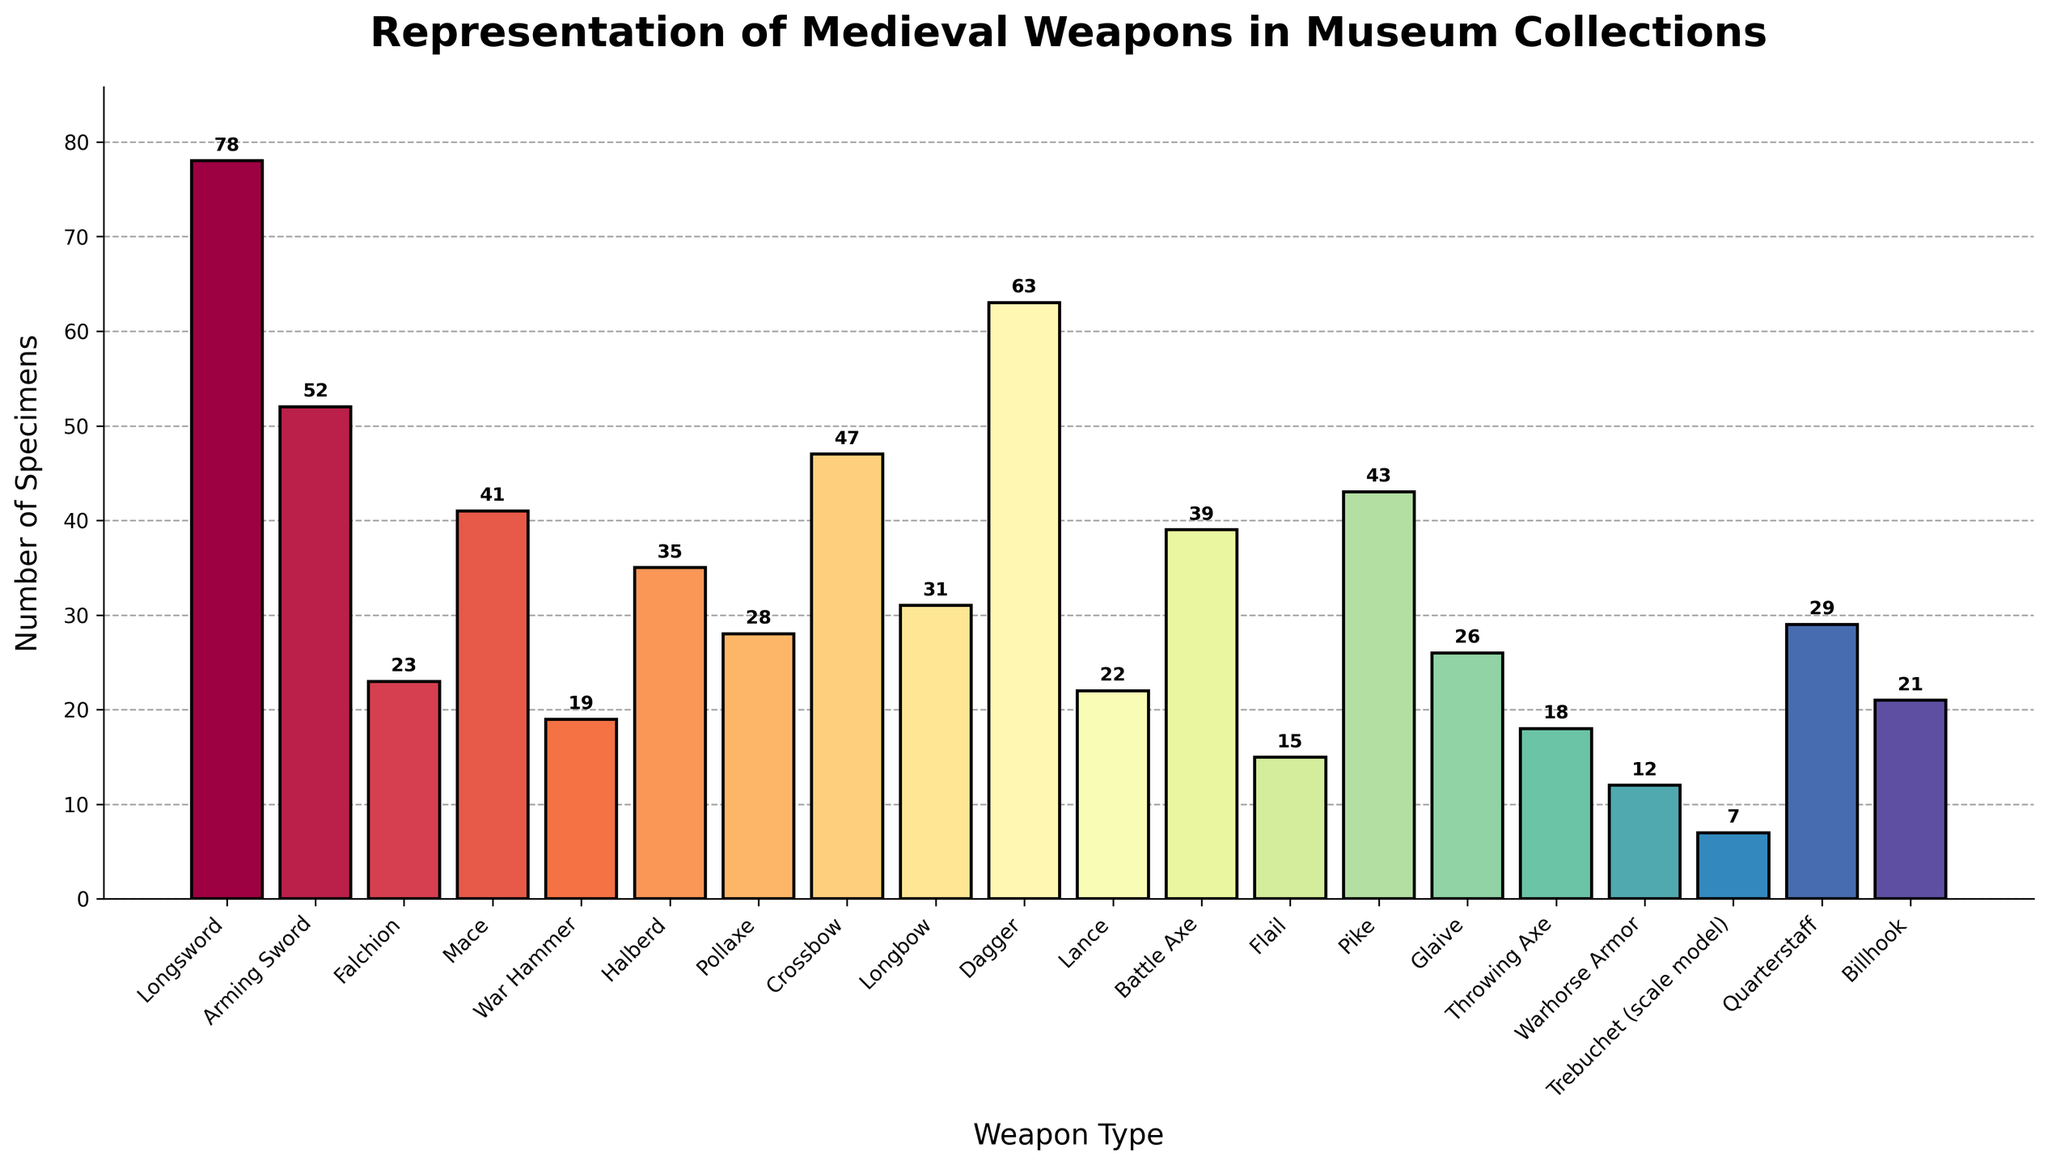What is the most represented weapon type in the museum collections? The highest bar on the chart represents the most represented weapon. The Longsword has the highest number with 78 specimens.
Answer: Longsword Which weapon type is the least represented in the museum collections? The shortest bar on the chart represents the least represented weapon. The Trebuchet (scale model) has the lowest number with 7 specimens.
Answer: Trebuchet (scale model) How many more specimens of Daggers are there compared to Flails? To find the difference, subtract the number of Flails from the number of Daggers (63 - 15).
Answer: 48 Which has more specimens, Crossbows or Longbows? Compare the heights of the bars for Crossbows (47 specimens) and Longbows (31 specimens). The Crossbow bar is taller.
Answer: Crossbows If you combine the counts of Maces and War Hammers, do they exceed the count of Longswords? Add the number of Maces (41) and War Hammers (19), and compare the sum to the Longswords. 41 + 19 = 60, which is less than 78 (Longswords).
Answer: No How many weapons have more than 30 specimens? Count the bars with heights greater than 30: Longsword, Arming Sword, Dagger, Crossbow, Halberd, Pike, Battle Axe, and Quarterstaff. There are 8 such weapons.
Answer: 8 What is the visual color trend in the bar chart? The colors in the chart follow a gradient pattern using the Spectral colormap, transitioning smoothly through a spectrum.
Answer: Gradient spectrum Which weapon type just exceeds the 50 specimen mark? Look for the bar slightly above the 50 mark. The Arming Sword has 52 specimens.
Answer: Arming Sword What is the difference in the number of specimens between the Battle Axe and the Pike? Subtract the number of Battle Axe specimens from Pike (43 - 39).
Answer: 4 Which three weapon types have their specimen count closest to the median of the dataset? To find the median count, sort the numbers and choose the middle value(s). The specimen counts sorted are: 7, 12, 15, 18, 19, 21, 22, 23, 26, 28, 29, 31, 35, 39, 41, 43, 47, 52, 63, 78. The median is the average of 29 and 31, which is 30. The three closest counts are Halberd (35), Quarterstaff (29), and Longbow (31).
Answer: Halberd, Quarterstaff, Longbow 